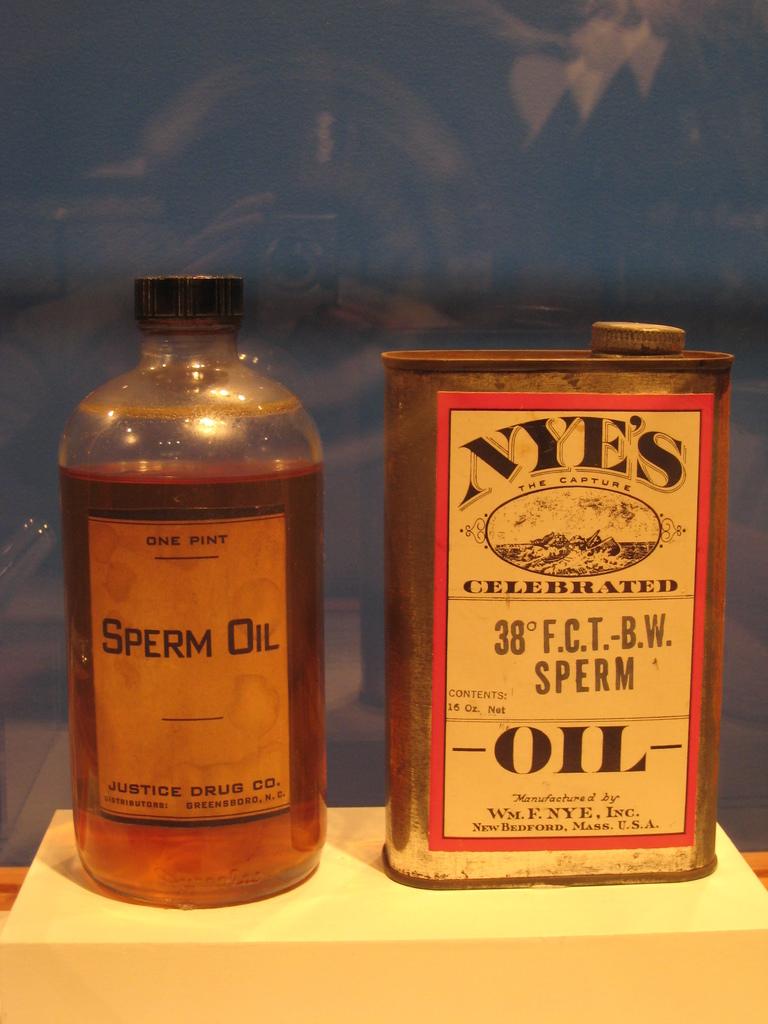What kind of oil is sitting on the self?
Your answer should be very brief. Sperm. Is the left bottle one or two pints?
Make the answer very short. One. 